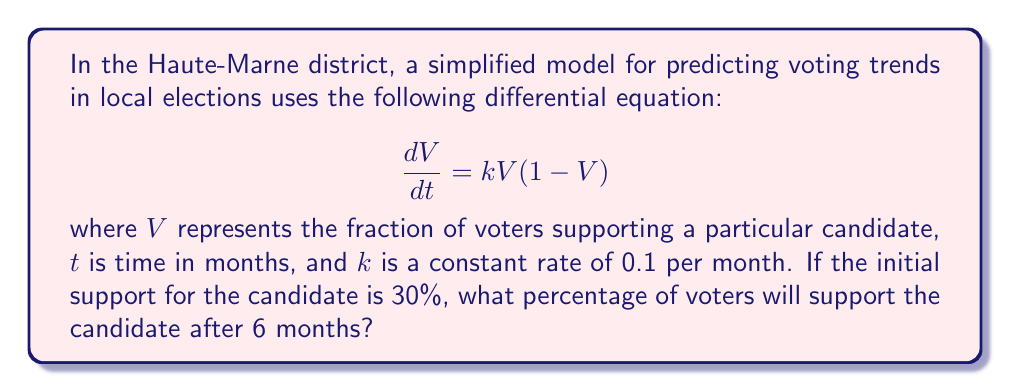Give your solution to this math problem. To solve this problem, we'll follow these steps:

1) The given differential equation is a logistic growth model:
   $$\frac{dV}{dt} = kV(1-V)$$

2) The solution to this equation is:
   $$V(t) = \frac{V_0}{V_0 + (1-V_0)e^{-kt}}$$
   where $V_0$ is the initial fraction of voters supporting the candidate.

3) We're given:
   - $k = 0.1$ per month
   - $V_0 = 30\% = 0.3$
   - $t = 6$ months

4) Let's substitute these values into our solution:
   $$V(6) = \frac{0.3}{0.3 + (1-0.3)e^{-0.1 \cdot 6}}$$

5) Simplify:
   $$V(6) = \frac{0.3}{0.3 + 0.7e^{-0.6}}$$

6) Calculate $e^{-0.6} \approx 0.5488$:
   $$V(6) = \frac{0.3}{0.3 + 0.7 \cdot 0.5488} \approx 0.4377$$

7) Convert to a percentage:
   $0.4377 \cdot 100\% \approx 43.77\%$

Therefore, after 6 months, approximately 43.77% of voters will support the candidate.
Answer: 43.77% 